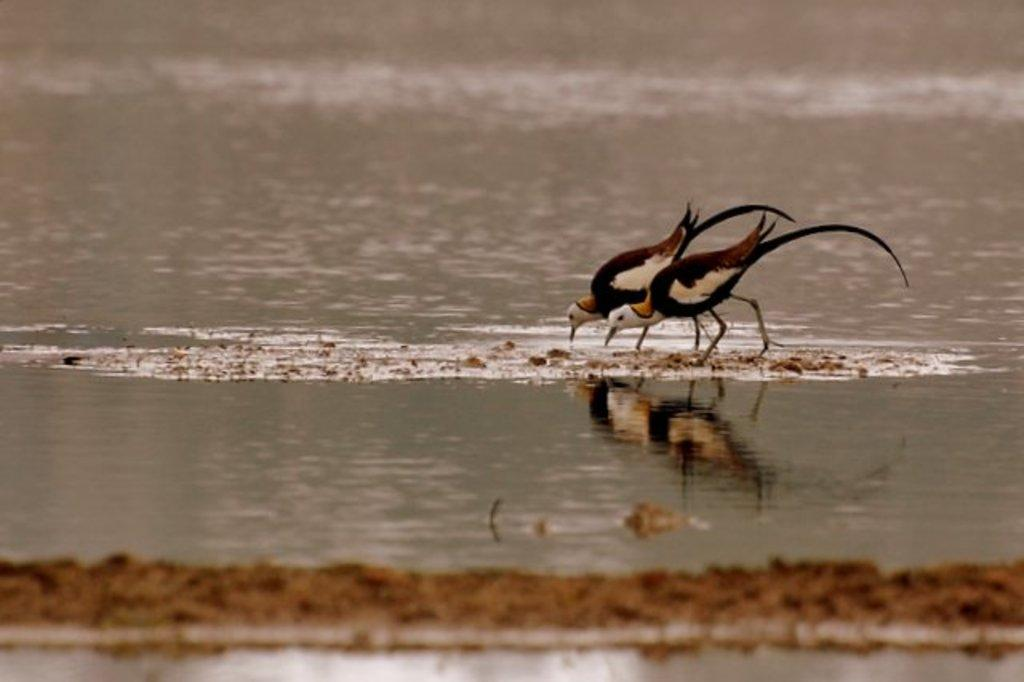How many birds are present in the image? There are two birds in the image. What are the birds doing in the image? The birds are drinking water. Can you describe the element that the birds are interacting with? There is water visible in the image. What type of debt is the bird on the left side of the image facing? There is no mention of debt in the image, and the birds are not facing any financial issues. 